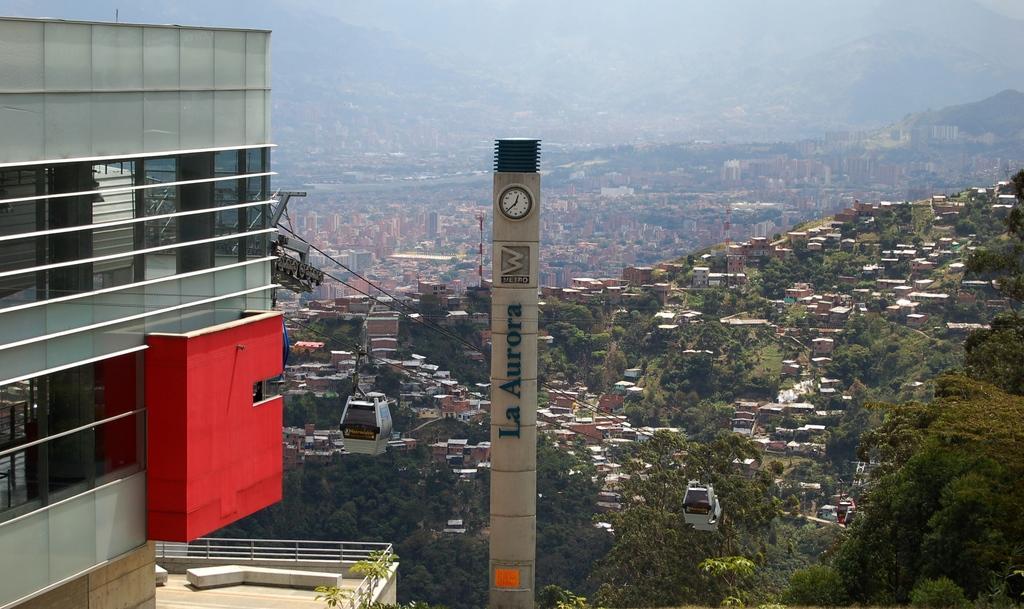How would you summarize this image in a sentence or two? In the bottom left corner of the image we can see a building, on the building we can see a ropeway. Behind the rope way we can see some trees and buildings. At the top of the image we can see some hills. In the middle of the image we can see a clock tower. 